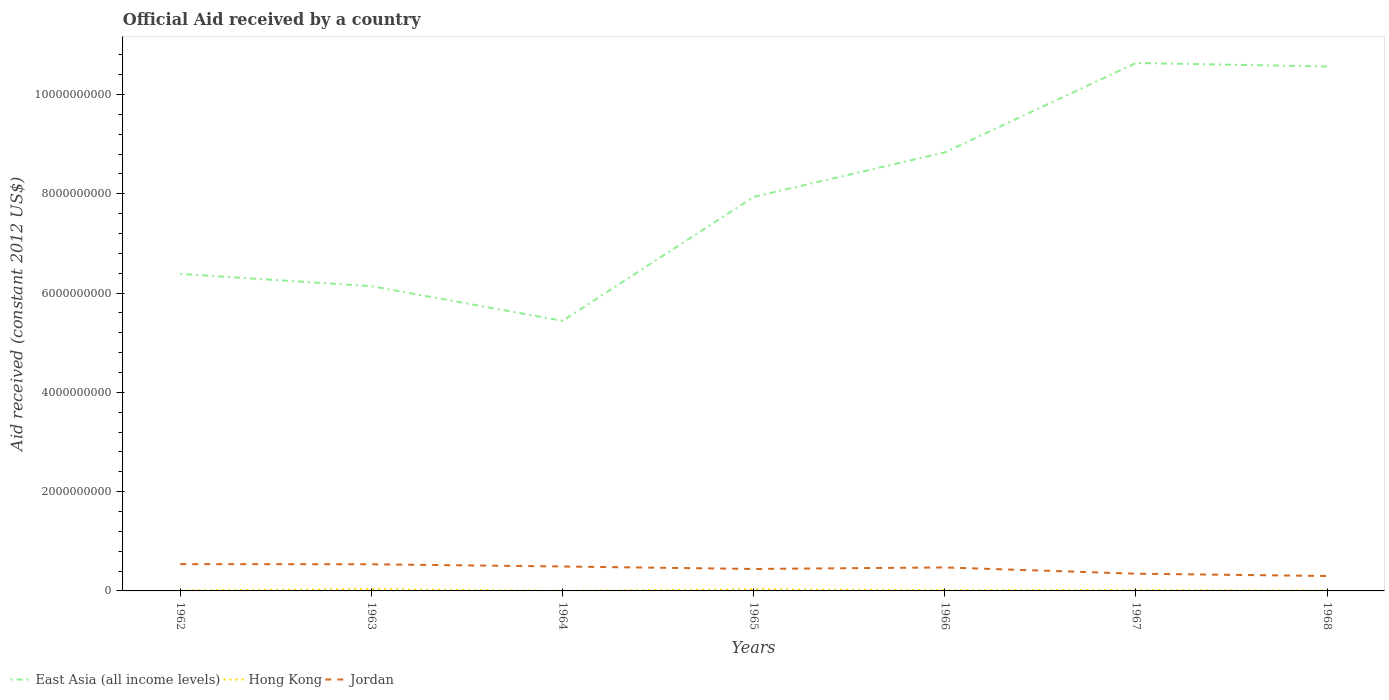How many different coloured lines are there?
Your answer should be very brief. 3. Is the number of lines equal to the number of legend labels?
Keep it short and to the point. Yes. Across all years, what is the maximum net official aid received in Hong Kong?
Offer a terse response. 2.08e+06. In which year was the net official aid received in East Asia (all income levels) maximum?
Your answer should be very brief. 1964. What is the total net official aid received in Jordan in the graph?
Your answer should be compact. 2.39e+08. What is the difference between the highest and the second highest net official aid received in Jordan?
Provide a succinct answer. 2.39e+08. Does the graph contain any zero values?
Give a very brief answer. No. Does the graph contain grids?
Offer a terse response. No. Where does the legend appear in the graph?
Make the answer very short. Bottom left. What is the title of the graph?
Your answer should be compact. Official Aid received by a country. Does "Romania" appear as one of the legend labels in the graph?
Your response must be concise. No. What is the label or title of the Y-axis?
Offer a terse response. Aid received (constant 2012 US$). What is the Aid received (constant 2012 US$) in East Asia (all income levels) in 1962?
Provide a short and direct response. 6.39e+09. What is the Aid received (constant 2012 US$) of Hong Kong in 1962?
Keep it short and to the point. 1.08e+07. What is the Aid received (constant 2012 US$) in Jordan in 1962?
Make the answer very short. 5.40e+08. What is the Aid received (constant 2012 US$) of East Asia (all income levels) in 1963?
Your answer should be very brief. 6.14e+09. What is the Aid received (constant 2012 US$) in Hong Kong in 1963?
Your answer should be compact. 3.70e+07. What is the Aid received (constant 2012 US$) of Jordan in 1963?
Offer a very short reply. 5.37e+08. What is the Aid received (constant 2012 US$) in East Asia (all income levels) in 1964?
Your answer should be compact. 5.44e+09. What is the Aid received (constant 2012 US$) in Hong Kong in 1964?
Offer a terse response. 2.08e+06. What is the Aid received (constant 2012 US$) of Jordan in 1964?
Provide a short and direct response. 4.92e+08. What is the Aid received (constant 2012 US$) in East Asia (all income levels) in 1965?
Make the answer very short. 7.94e+09. What is the Aid received (constant 2012 US$) in Hong Kong in 1965?
Keep it short and to the point. 3.34e+07. What is the Aid received (constant 2012 US$) of Jordan in 1965?
Offer a very short reply. 4.42e+08. What is the Aid received (constant 2012 US$) of East Asia (all income levels) in 1966?
Make the answer very short. 8.84e+09. What is the Aid received (constant 2012 US$) of Hong Kong in 1966?
Keep it short and to the point. 1.55e+07. What is the Aid received (constant 2012 US$) in Jordan in 1966?
Offer a terse response. 4.73e+08. What is the Aid received (constant 2012 US$) in East Asia (all income levels) in 1967?
Your response must be concise. 1.06e+1. What is the Aid received (constant 2012 US$) in Hong Kong in 1967?
Ensure brevity in your answer.  1.72e+07. What is the Aid received (constant 2012 US$) in Jordan in 1967?
Offer a terse response. 3.47e+08. What is the Aid received (constant 2012 US$) in East Asia (all income levels) in 1968?
Your response must be concise. 1.06e+1. What is the Aid received (constant 2012 US$) of Hong Kong in 1968?
Offer a terse response. 8.51e+06. What is the Aid received (constant 2012 US$) in Jordan in 1968?
Offer a terse response. 3.01e+08. Across all years, what is the maximum Aid received (constant 2012 US$) in East Asia (all income levels)?
Keep it short and to the point. 1.06e+1. Across all years, what is the maximum Aid received (constant 2012 US$) in Hong Kong?
Your answer should be compact. 3.70e+07. Across all years, what is the maximum Aid received (constant 2012 US$) in Jordan?
Your answer should be compact. 5.40e+08. Across all years, what is the minimum Aid received (constant 2012 US$) in East Asia (all income levels)?
Make the answer very short. 5.44e+09. Across all years, what is the minimum Aid received (constant 2012 US$) of Hong Kong?
Provide a short and direct response. 2.08e+06. Across all years, what is the minimum Aid received (constant 2012 US$) of Jordan?
Provide a succinct answer. 3.01e+08. What is the total Aid received (constant 2012 US$) in East Asia (all income levels) in the graph?
Give a very brief answer. 5.59e+1. What is the total Aid received (constant 2012 US$) in Hong Kong in the graph?
Make the answer very short. 1.24e+08. What is the total Aid received (constant 2012 US$) in Jordan in the graph?
Your answer should be very brief. 3.13e+09. What is the difference between the Aid received (constant 2012 US$) of East Asia (all income levels) in 1962 and that in 1963?
Make the answer very short. 2.47e+08. What is the difference between the Aid received (constant 2012 US$) of Hong Kong in 1962 and that in 1963?
Make the answer very short. -2.62e+07. What is the difference between the Aid received (constant 2012 US$) in Jordan in 1962 and that in 1963?
Your answer should be very brief. 2.85e+06. What is the difference between the Aid received (constant 2012 US$) of East Asia (all income levels) in 1962 and that in 1964?
Give a very brief answer. 9.46e+08. What is the difference between the Aid received (constant 2012 US$) in Hong Kong in 1962 and that in 1964?
Keep it short and to the point. 8.74e+06. What is the difference between the Aid received (constant 2012 US$) in Jordan in 1962 and that in 1964?
Offer a very short reply. 4.77e+07. What is the difference between the Aid received (constant 2012 US$) in East Asia (all income levels) in 1962 and that in 1965?
Your answer should be compact. -1.55e+09. What is the difference between the Aid received (constant 2012 US$) in Hong Kong in 1962 and that in 1965?
Keep it short and to the point. -2.26e+07. What is the difference between the Aid received (constant 2012 US$) in Jordan in 1962 and that in 1965?
Provide a succinct answer. 9.74e+07. What is the difference between the Aid received (constant 2012 US$) in East Asia (all income levels) in 1962 and that in 1966?
Keep it short and to the point. -2.45e+09. What is the difference between the Aid received (constant 2012 US$) in Hong Kong in 1962 and that in 1966?
Provide a succinct answer. -4.64e+06. What is the difference between the Aid received (constant 2012 US$) of Jordan in 1962 and that in 1966?
Give a very brief answer. 6.68e+07. What is the difference between the Aid received (constant 2012 US$) of East Asia (all income levels) in 1962 and that in 1967?
Make the answer very short. -4.25e+09. What is the difference between the Aid received (constant 2012 US$) in Hong Kong in 1962 and that in 1967?
Offer a terse response. -6.36e+06. What is the difference between the Aid received (constant 2012 US$) of Jordan in 1962 and that in 1967?
Provide a succinct answer. 1.93e+08. What is the difference between the Aid received (constant 2012 US$) in East Asia (all income levels) in 1962 and that in 1968?
Ensure brevity in your answer.  -4.18e+09. What is the difference between the Aid received (constant 2012 US$) in Hong Kong in 1962 and that in 1968?
Ensure brevity in your answer.  2.31e+06. What is the difference between the Aid received (constant 2012 US$) in Jordan in 1962 and that in 1968?
Give a very brief answer. 2.39e+08. What is the difference between the Aid received (constant 2012 US$) of East Asia (all income levels) in 1963 and that in 1964?
Ensure brevity in your answer.  6.99e+08. What is the difference between the Aid received (constant 2012 US$) in Hong Kong in 1963 and that in 1964?
Your answer should be compact. 3.50e+07. What is the difference between the Aid received (constant 2012 US$) in Jordan in 1963 and that in 1964?
Your answer should be very brief. 4.49e+07. What is the difference between the Aid received (constant 2012 US$) of East Asia (all income levels) in 1963 and that in 1965?
Your answer should be compact. -1.80e+09. What is the difference between the Aid received (constant 2012 US$) of Hong Kong in 1963 and that in 1965?
Offer a very short reply. 3.67e+06. What is the difference between the Aid received (constant 2012 US$) in Jordan in 1963 and that in 1965?
Your response must be concise. 9.45e+07. What is the difference between the Aid received (constant 2012 US$) of East Asia (all income levels) in 1963 and that in 1966?
Make the answer very short. -2.70e+09. What is the difference between the Aid received (constant 2012 US$) in Hong Kong in 1963 and that in 1966?
Your answer should be very brief. 2.16e+07. What is the difference between the Aid received (constant 2012 US$) of Jordan in 1963 and that in 1966?
Your response must be concise. 6.40e+07. What is the difference between the Aid received (constant 2012 US$) in East Asia (all income levels) in 1963 and that in 1967?
Your answer should be compact. -4.50e+09. What is the difference between the Aid received (constant 2012 US$) in Hong Kong in 1963 and that in 1967?
Provide a succinct answer. 1.99e+07. What is the difference between the Aid received (constant 2012 US$) in Jordan in 1963 and that in 1967?
Offer a very short reply. 1.90e+08. What is the difference between the Aid received (constant 2012 US$) in East Asia (all income levels) in 1963 and that in 1968?
Make the answer very short. -4.42e+09. What is the difference between the Aid received (constant 2012 US$) of Hong Kong in 1963 and that in 1968?
Your answer should be compact. 2.85e+07. What is the difference between the Aid received (constant 2012 US$) of Jordan in 1963 and that in 1968?
Ensure brevity in your answer.  2.36e+08. What is the difference between the Aid received (constant 2012 US$) in East Asia (all income levels) in 1964 and that in 1965?
Provide a short and direct response. -2.50e+09. What is the difference between the Aid received (constant 2012 US$) in Hong Kong in 1964 and that in 1965?
Your response must be concise. -3.13e+07. What is the difference between the Aid received (constant 2012 US$) in Jordan in 1964 and that in 1965?
Ensure brevity in your answer.  4.97e+07. What is the difference between the Aid received (constant 2012 US$) of East Asia (all income levels) in 1964 and that in 1966?
Provide a short and direct response. -3.39e+09. What is the difference between the Aid received (constant 2012 US$) of Hong Kong in 1964 and that in 1966?
Ensure brevity in your answer.  -1.34e+07. What is the difference between the Aid received (constant 2012 US$) of Jordan in 1964 and that in 1966?
Your answer should be very brief. 1.91e+07. What is the difference between the Aid received (constant 2012 US$) of East Asia (all income levels) in 1964 and that in 1967?
Give a very brief answer. -5.20e+09. What is the difference between the Aid received (constant 2012 US$) in Hong Kong in 1964 and that in 1967?
Provide a short and direct response. -1.51e+07. What is the difference between the Aid received (constant 2012 US$) of Jordan in 1964 and that in 1967?
Provide a succinct answer. 1.45e+08. What is the difference between the Aid received (constant 2012 US$) in East Asia (all income levels) in 1964 and that in 1968?
Keep it short and to the point. -5.12e+09. What is the difference between the Aid received (constant 2012 US$) of Hong Kong in 1964 and that in 1968?
Your answer should be compact. -6.43e+06. What is the difference between the Aid received (constant 2012 US$) in Jordan in 1964 and that in 1968?
Offer a terse response. 1.91e+08. What is the difference between the Aid received (constant 2012 US$) of East Asia (all income levels) in 1965 and that in 1966?
Offer a very short reply. -8.97e+08. What is the difference between the Aid received (constant 2012 US$) in Hong Kong in 1965 and that in 1966?
Your answer should be very brief. 1.79e+07. What is the difference between the Aid received (constant 2012 US$) of Jordan in 1965 and that in 1966?
Give a very brief answer. -3.06e+07. What is the difference between the Aid received (constant 2012 US$) in East Asia (all income levels) in 1965 and that in 1967?
Your answer should be compact. -2.70e+09. What is the difference between the Aid received (constant 2012 US$) in Hong Kong in 1965 and that in 1967?
Provide a short and direct response. 1.62e+07. What is the difference between the Aid received (constant 2012 US$) of Jordan in 1965 and that in 1967?
Your answer should be very brief. 9.51e+07. What is the difference between the Aid received (constant 2012 US$) of East Asia (all income levels) in 1965 and that in 1968?
Make the answer very short. -2.63e+09. What is the difference between the Aid received (constant 2012 US$) in Hong Kong in 1965 and that in 1968?
Your answer should be very brief. 2.49e+07. What is the difference between the Aid received (constant 2012 US$) in Jordan in 1965 and that in 1968?
Make the answer very short. 1.42e+08. What is the difference between the Aid received (constant 2012 US$) of East Asia (all income levels) in 1966 and that in 1967?
Your answer should be very brief. -1.80e+09. What is the difference between the Aid received (constant 2012 US$) of Hong Kong in 1966 and that in 1967?
Keep it short and to the point. -1.72e+06. What is the difference between the Aid received (constant 2012 US$) of Jordan in 1966 and that in 1967?
Ensure brevity in your answer.  1.26e+08. What is the difference between the Aid received (constant 2012 US$) in East Asia (all income levels) in 1966 and that in 1968?
Provide a succinct answer. -1.73e+09. What is the difference between the Aid received (constant 2012 US$) in Hong Kong in 1966 and that in 1968?
Ensure brevity in your answer.  6.95e+06. What is the difference between the Aid received (constant 2012 US$) in Jordan in 1966 and that in 1968?
Ensure brevity in your answer.  1.72e+08. What is the difference between the Aid received (constant 2012 US$) in East Asia (all income levels) in 1967 and that in 1968?
Your answer should be very brief. 7.13e+07. What is the difference between the Aid received (constant 2012 US$) of Hong Kong in 1967 and that in 1968?
Your response must be concise. 8.67e+06. What is the difference between the Aid received (constant 2012 US$) of Jordan in 1967 and that in 1968?
Offer a terse response. 4.67e+07. What is the difference between the Aid received (constant 2012 US$) in East Asia (all income levels) in 1962 and the Aid received (constant 2012 US$) in Hong Kong in 1963?
Give a very brief answer. 6.35e+09. What is the difference between the Aid received (constant 2012 US$) of East Asia (all income levels) in 1962 and the Aid received (constant 2012 US$) of Jordan in 1963?
Your answer should be compact. 5.85e+09. What is the difference between the Aid received (constant 2012 US$) in Hong Kong in 1962 and the Aid received (constant 2012 US$) in Jordan in 1963?
Keep it short and to the point. -5.26e+08. What is the difference between the Aid received (constant 2012 US$) of East Asia (all income levels) in 1962 and the Aid received (constant 2012 US$) of Hong Kong in 1964?
Your answer should be compact. 6.38e+09. What is the difference between the Aid received (constant 2012 US$) of East Asia (all income levels) in 1962 and the Aid received (constant 2012 US$) of Jordan in 1964?
Your answer should be very brief. 5.89e+09. What is the difference between the Aid received (constant 2012 US$) of Hong Kong in 1962 and the Aid received (constant 2012 US$) of Jordan in 1964?
Offer a terse response. -4.81e+08. What is the difference between the Aid received (constant 2012 US$) of East Asia (all income levels) in 1962 and the Aid received (constant 2012 US$) of Hong Kong in 1965?
Your answer should be compact. 6.35e+09. What is the difference between the Aid received (constant 2012 US$) of East Asia (all income levels) in 1962 and the Aid received (constant 2012 US$) of Jordan in 1965?
Your answer should be very brief. 5.94e+09. What is the difference between the Aid received (constant 2012 US$) in Hong Kong in 1962 and the Aid received (constant 2012 US$) in Jordan in 1965?
Offer a terse response. -4.32e+08. What is the difference between the Aid received (constant 2012 US$) in East Asia (all income levels) in 1962 and the Aid received (constant 2012 US$) in Hong Kong in 1966?
Offer a terse response. 6.37e+09. What is the difference between the Aid received (constant 2012 US$) in East Asia (all income levels) in 1962 and the Aid received (constant 2012 US$) in Jordan in 1966?
Give a very brief answer. 5.91e+09. What is the difference between the Aid received (constant 2012 US$) of Hong Kong in 1962 and the Aid received (constant 2012 US$) of Jordan in 1966?
Your answer should be very brief. -4.62e+08. What is the difference between the Aid received (constant 2012 US$) in East Asia (all income levels) in 1962 and the Aid received (constant 2012 US$) in Hong Kong in 1967?
Offer a very short reply. 6.37e+09. What is the difference between the Aid received (constant 2012 US$) of East Asia (all income levels) in 1962 and the Aid received (constant 2012 US$) of Jordan in 1967?
Give a very brief answer. 6.04e+09. What is the difference between the Aid received (constant 2012 US$) in Hong Kong in 1962 and the Aid received (constant 2012 US$) in Jordan in 1967?
Provide a succinct answer. -3.36e+08. What is the difference between the Aid received (constant 2012 US$) in East Asia (all income levels) in 1962 and the Aid received (constant 2012 US$) in Hong Kong in 1968?
Your answer should be compact. 6.38e+09. What is the difference between the Aid received (constant 2012 US$) in East Asia (all income levels) in 1962 and the Aid received (constant 2012 US$) in Jordan in 1968?
Provide a succinct answer. 6.09e+09. What is the difference between the Aid received (constant 2012 US$) in Hong Kong in 1962 and the Aid received (constant 2012 US$) in Jordan in 1968?
Give a very brief answer. -2.90e+08. What is the difference between the Aid received (constant 2012 US$) in East Asia (all income levels) in 1963 and the Aid received (constant 2012 US$) in Hong Kong in 1964?
Your response must be concise. 6.14e+09. What is the difference between the Aid received (constant 2012 US$) in East Asia (all income levels) in 1963 and the Aid received (constant 2012 US$) in Jordan in 1964?
Ensure brevity in your answer.  5.65e+09. What is the difference between the Aid received (constant 2012 US$) of Hong Kong in 1963 and the Aid received (constant 2012 US$) of Jordan in 1964?
Ensure brevity in your answer.  -4.55e+08. What is the difference between the Aid received (constant 2012 US$) in East Asia (all income levels) in 1963 and the Aid received (constant 2012 US$) in Hong Kong in 1965?
Offer a terse response. 6.11e+09. What is the difference between the Aid received (constant 2012 US$) of East Asia (all income levels) in 1963 and the Aid received (constant 2012 US$) of Jordan in 1965?
Offer a very short reply. 5.70e+09. What is the difference between the Aid received (constant 2012 US$) of Hong Kong in 1963 and the Aid received (constant 2012 US$) of Jordan in 1965?
Offer a terse response. -4.05e+08. What is the difference between the Aid received (constant 2012 US$) in East Asia (all income levels) in 1963 and the Aid received (constant 2012 US$) in Hong Kong in 1966?
Offer a very short reply. 6.12e+09. What is the difference between the Aid received (constant 2012 US$) of East Asia (all income levels) in 1963 and the Aid received (constant 2012 US$) of Jordan in 1966?
Ensure brevity in your answer.  5.67e+09. What is the difference between the Aid received (constant 2012 US$) in Hong Kong in 1963 and the Aid received (constant 2012 US$) in Jordan in 1966?
Ensure brevity in your answer.  -4.36e+08. What is the difference between the Aid received (constant 2012 US$) in East Asia (all income levels) in 1963 and the Aid received (constant 2012 US$) in Hong Kong in 1967?
Keep it short and to the point. 6.12e+09. What is the difference between the Aid received (constant 2012 US$) in East Asia (all income levels) in 1963 and the Aid received (constant 2012 US$) in Jordan in 1967?
Provide a short and direct response. 5.79e+09. What is the difference between the Aid received (constant 2012 US$) in Hong Kong in 1963 and the Aid received (constant 2012 US$) in Jordan in 1967?
Your answer should be very brief. -3.10e+08. What is the difference between the Aid received (constant 2012 US$) in East Asia (all income levels) in 1963 and the Aid received (constant 2012 US$) in Hong Kong in 1968?
Give a very brief answer. 6.13e+09. What is the difference between the Aid received (constant 2012 US$) in East Asia (all income levels) in 1963 and the Aid received (constant 2012 US$) in Jordan in 1968?
Provide a succinct answer. 5.84e+09. What is the difference between the Aid received (constant 2012 US$) of Hong Kong in 1963 and the Aid received (constant 2012 US$) of Jordan in 1968?
Offer a very short reply. -2.64e+08. What is the difference between the Aid received (constant 2012 US$) of East Asia (all income levels) in 1964 and the Aid received (constant 2012 US$) of Hong Kong in 1965?
Give a very brief answer. 5.41e+09. What is the difference between the Aid received (constant 2012 US$) in East Asia (all income levels) in 1964 and the Aid received (constant 2012 US$) in Jordan in 1965?
Ensure brevity in your answer.  5.00e+09. What is the difference between the Aid received (constant 2012 US$) of Hong Kong in 1964 and the Aid received (constant 2012 US$) of Jordan in 1965?
Provide a succinct answer. -4.40e+08. What is the difference between the Aid received (constant 2012 US$) of East Asia (all income levels) in 1964 and the Aid received (constant 2012 US$) of Hong Kong in 1966?
Offer a terse response. 5.42e+09. What is the difference between the Aid received (constant 2012 US$) of East Asia (all income levels) in 1964 and the Aid received (constant 2012 US$) of Jordan in 1966?
Your answer should be very brief. 4.97e+09. What is the difference between the Aid received (constant 2012 US$) in Hong Kong in 1964 and the Aid received (constant 2012 US$) in Jordan in 1966?
Make the answer very short. -4.71e+08. What is the difference between the Aid received (constant 2012 US$) of East Asia (all income levels) in 1964 and the Aid received (constant 2012 US$) of Hong Kong in 1967?
Give a very brief answer. 5.42e+09. What is the difference between the Aid received (constant 2012 US$) of East Asia (all income levels) in 1964 and the Aid received (constant 2012 US$) of Jordan in 1967?
Your answer should be compact. 5.09e+09. What is the difference between the Aid received (constant 2012 US$) of Hong Kong in 1964 and the Aid received (constant 2012 US$) of Jordan in 1967?
Your response must be concise. -3.45e+08. What is the difference between the Aid received (constant 2012 US$) in East Asia (all income levels) in 1964 and the Aid received (constant 2012 US$) in Hong Kong in 1968?
Your response must be concise. 5.43e+09. What is the difference between the Aid received (constant 2012 US$) in East Asia (all income levels) in 1964 and the Aid received (constant 2012 US$) in Jordan in 1968?
Your answer should be compact. 5.14e+09. What is the difference between the Aid received (constant 2012 US$) of Hong Kong in 1964 and the Aid received (constant 2012 US$) of Jordan in 1968?
Your response must be concise. -2.99e+08. What is the difference between the Aid received (constant 2012 US$) in East Asia (all income levels) in 1965 and the Aid received (constant 2012 US$) in Hong Kong in 1966?
Make the answer very short. 7.92e+09. What is the difference between the Aid received (constant 2012 US$) of East Asia (all income levels) in 1965 and the Aid received (constant 2012 US$) of Jordan in 1966?
Ensure brevity in your answer.  7.46e+09. What is the difference between the Aid received (constant 2012 US$) in Hong Kong in 1965 and the Aid received (constant 2012 US$) in Jordan in 1966?
Your response must be concise. -4.40e+08. What is the difference between the Aid received (constant 2012 US$) in East Asia (all income levels) in 1965 and the Aid received (constant 2012 US$) in Hong Kong in 1967?
Offer a very short reply. 7.92e+09. What is the difference between the Aid received (constant 2012 US$) in East Asia (all income levels) in 1965 and the Aid received (constant 2012 US$) in Jordan in 1967?
Offer a very short reply. 7.59e+09. What is the difference between the Aid received (constant 2012 US$) of Hong Kong in 1965 and the Aid received (constant 2012 US$) of Jordan in 1967?
Provide a short and direct response. -3.14e+08. What is the difference between the Aid received (constant 2012 US$) in East Asia (all income levels) in 1965 and the Aid received (constant 2012 US$) in Hong Kong in 1968?
Your answer should be compact. 7.93e+09. What is the difference between the Aid received (constant 2012 US$) in East Asia (all income levels) in 1965 and the Aid received (constant 2012 US$) in Jordan in 1968?
Provide a succinct answer. 7.64e+09. What is the difference between the Aid received (constant 2012 US$) of Hong Kong in 1965 and the Aid received (constant 2012 US$) of Jordan in 1968?
Provide a short and direct response. -2.67e+08. What is the difference between the Aid received (constant 2012 US$) in East Asia (all income levels) in 1966 and the Aid received (constant 2012 US$) in Hong Kong in 1967?
Keep it short and to the point. 8.82e+09. What is the difference between the Aid received (constant 2012 US$) of East Asia (all income levels) in 1966 and the Aid received (constant 2012 US$) of Jordan in 1967?
Offer a terse response. 8.49e+09. What is the difference between the Aid received (constant 2012 US$) in Hong Kong in 1966 and the Aid received (constant 2012 US$) in Jordan in 1967?
Give a very brief answer. -3.32e+08. What is the difference between the Aid received (constant 2012 US$) of East Asia (all income levels) in 1966 and the Aid received (constant 2012 US$) of Hong Kong in 1968?
Provide a succinct answer. 8.83e+09. What is the difference between the Aid received (constant 2012 US$) of East Asia (all income levels) in 1966 and the Aid received (constant 2012 US$) of Jordan in 1968?
Offer a very short reply. 8.53e+09. What is the difference between the Aid received (constant 2012 US$) in Hong Kong in 1966 and the Aid received (constant 2012 US$) in Jordan in 1968?
Provide a short and direct response. -2.85e+08. What is the difference between the Aid received (constant 2012 US$) of East Asia (all income levels) in 1967 and the Aid received (constant 2012 US$) of Hong Kong in 1968?
Give a very brief answer. 1.06e+1. What is the difference between the Aid received (constant 2012 US$) of East Asia (all income levels) in 1967 and the Aid received (constant 2012 US$) of Jordan in 1968?
Give a very brief answer. 1.03e+1. What is the difference between the Aid received (constant 2012 US$) in Hong Kong in 1967 and the Aid received (constant 2012 US$) in Jordan in 1968?
Offer a terse response. -2.83e+08. What is the average Aid received (constant 2012 US$) in East Asia (all income levels) per year?
Provide a short and direct response. 7.99e+09. What is the average Aid received (constant 2012 US$) of Hong Kong per year?
Give a very brief answer. 1.78e+07. What is the average Aid received (constant 2012 US$) in Jordan per year?
Your answer should be compact. 4.47e+08. In the year 1962, what is the difference between the Aid received (constant 2012 US$) in East Asia (all income levels) and Aid received (constant 2012 US$) in Hong Kong?
Provide a succinct answer. 6.38e+09. In the year 1962, what is the difference between the Aid received (constant 2012 US$) in East Asia (all income levels) and Aid received (constant 2012 US$) in Jordan?
Make the answer very short. 5.85e+09. In the year 1962, what is the difference between the Aid received (constant 2012 US$) in Hong Kong and Aid received (constant 2012 US$) in Jordan?
Make the answer very short. -5.29e+08. In the year 1963, what is the difference between the Aid received (constant 2012 US$) of East Asia (all income levels) and Aid received (constant 2012 US$) of Hong Kong?
Provide a succinct answer. 6.10e+09. In the year 1963, what is the difference between the Aid received (constant 2012 US$) in East Asia (all income levels) and Aid received (constant 2012 US$) in Jordan?
Make the answer very short. 5.60e+09. In the year 1963, what is the difference between the Aid received (constant 2012 US$) of Hong Kong and Aid received (constant 2012 US$) of Jordan?
Keep it short and to the point. -5.00e+08. In the year 1964, what is the difference between the Aid received (constant 2012 US$) in East Asia (all income levels) and Aid received (constant 2012 US$) in Hong Kong?
Your response must be concise. 5.44e+09. In the year 1964, what is the difference between the Aid received (constant 2012 US$) of East Asia (all income levels) and Aid received (constant 2012 US$) of Jordan?
Provide a short and direct response. 4.95e+09. In the year 1964, what is the difference between the Aid received (constant 2012 US$) of Hong Kong and Aid received (constant 2012 US$) of Jordan?
Make the answer very short. -4.90e+08. In the year 1965, what is the difference between the Aid received (constant 2012 US$) in East Asia (all income levels) and Aid received (constant 2012 US$) in Hong Kong?
Offer a terse response. 7.90e+09. In the year 1965, what is the difference between the Aid received (constant 2012 US$) of East Asia (all income levels) and Aid received (constant 2012 US$) of Jordan?
Offer a terse response. 7.50e+09. In the year 1965, what is the difference between the Aid received (constant 2012 US$) of Hong Kong and Aid received (constant 2012 US$) of Jordan?
Offer a terse response. -4.09e+08. In the year 1966, what is the difference between the Aid received (constant 2012 US$) in East Asia (all income levels) and Aid received (constant 2012 US$) in Hong Kong?
Offer a very short reply. 8.82e+09. In the year 1966, what is the difference between the Aid received (constant 2012 US$) of East Asia (all income levels) and Aid received (constant 2012 US$) of Jordan?
Offer a terse response. 8.36e+09. In the year 1966, what is the difference between the Aid received (constant 2012 US$) in Hong Kong and Aid received (constant 2012 US$) in Jordan?
Make the answer very short. -4.58e+08. In the year 1967, what is the difference between the Aid received (constant 2012 US$) of East Asia (all income levels) and Aid received (constant 2012 US$) of Hong Kong?
Offer a terse response. 1.06e+1. In the year 1967, what is the difference between the Aid received (constant 2012 US$) in East Asia (all income levels) and Aid received (constant 2012 US$) in Jordan?
Provide a succinct answer. 1.03e+1. In the year 1967, what is the difference between the Aid received (constant 2012 US$) of Hong Kong and Aid received (constant 2012 US$) of Jordan?
Your answer should be compact. -3.30e+08. In the year 1968, what is the difference between the Aid received (constant 2012 US$) of East Asia (all income levels) and Aid received (constant 2012 US$) of Hong Kong?
Make the answer very short. 1.06e+1. In the year 1968, what is the difference between the Aid received (constant 2012 US$) in East Asia (all income levels) and Aid received (constant 2012 US$) in Jordan?
Offer a terse response. 1.03e+1. In the year 1968, what is the difference between the Aid received (constant 2012 US$) in Hong Kong and Aid received (constant 2012 US$) in Jordan?
Give a very brief answer. -2.92e+08. What is the ratio of the Aid received (constant 2012 US$) of East Asia (all income levels) in 1962 to that in 1963?
Your answer should be very brief. 1.04. What is the ratio of the Aid received (constant 2012 US$) of Hong Kong in 1962 to that in 1963?
Offer a very short reply. 0.29. What is the ratio of the Aid received (constant 2012 US$) of Jordan in 1962 to that in 1963?
Offer a terse response. 1.01. What is the ratio of the Aid received (constant 2012 US$) of East Asia (all income levels) in 1962 to that in 1964?
Keep it short and to the point. 1.17. What is the ratio of the Aid received (constant 2012 US$) of Hong Kong in 1962 to that in 1964?
Your answer should be compact. 5.2. What is the ratio of the Aid received (constant 2012 US$) in Jordan in 1962 to that in 1964?
Your answer should be compact. 1.1. What is the ratio of the Aid received (constant 2012 US$) of East Asia (all income levels) in 1962 to that in 1965?
Ensure brevity in your answer.  0.8. What is the ratio of the Aid received (constant 2012 US$) in Hong Kong in 1962 to that in 1965?
Keep it short and to the point. 0.32. What is the ratio of the Aid received (constant 2012 US$) in Jordan in 1962 to that in 1965?
Offer a terse response. 1.22. What is the ratio of the Aid received (constant 2012 US$) in East Asia (all income levels) in 1962 to that in 1966?
Provide a short and direct response. 0.72. What is the ratio of the Aid received (constant 2012 US$) of Hong Kong in 1962 to that in 1966?
Provide a succinct answer. 0.7. What is the ratio of the Aid received (constant 2012 US$) in Jordan in 1962 to that in 1966?
Provide a short and direct response. 1.14. What is the ratio of the Aid received (constant 2012 US$) of East Asia (all income levels) in 1962 to that in 1967?
Your answer should be very brief. 0.6. What is the ratio of the Aid received (constant 2012 US$) in Hong Kong in 1962 to that in 1967?
Give a very brief answer. 0.63. What is the ratio of the Aid received (constant 2012 US$) of Jordan in 1962 to that in 1967?
Provide a succinct answer. 1.55. What is the ratio of the Aid received (constant 2012 US$) in East Asia (all income levels) in 1962 to that in 1968?
Give a very brief answer. 0.6. What is the ratio of the Aid received (constant 2012 US$) of Hong Kong in 1962 to that in 1968?
Provide a short and direct response. 1.27. What is the ratio of the Aid received (constant 2012 US$) of Jordan in 1962 to that in 1968?
Your answer should be very brief. 1.8. What is the ratio of the Aid received (constant 2012 US$) in East Asia (all income levels) in 1963 to that in 1964?
Your response must be concise. 1.13. What is the ratio of the Aid received (constant 2012 US$) in Hong Kong in 1963 to that in 1964?
Your response must be concise. 17.81. What is the ratio of the Aid received (constant 2012 US$) in Jordan in 1963 to that in 1964?
Provide a succinct answer. 1.09. What is the ratio of the Aid received (constant 2012 US$) in East Asia (all income levels) in 1963 to that in 1965?
Provide a succinct answer. 0.77. What is the ratio of the Aid received (constant 2012 US$) of Hong Kong in 1963 to that in 1965?
Your answer should be compact. 1.11. What is the ratio of the Aid received (constant 2012 US$) in Jordan in 1963 to that in 1965?
Your answer should be compact. 1.21. What is the ratio of the Aid received (constant 2012 US$) of East Asia (all income levels) in 1963 to that in 1966?
Ensure brevity in your answer.  0.69. What is the ratio of the Aid received (constant 2012 US$) of Hong Kong in 1963 to that in 1966?
Provide a short and direct response. 2.4. What is the ratio of the Aid received (constant 2012 US$) in Jordan in 1963 to that in 1966?
Ensure brevity in your answer.  1.14. What is the ratio of the Aid received (constant 2012 US$) of East Asia (all income levels) in 1963 to that in 1967?
Keep it short and to the point. 0.58. What is the ratio of the Aid received (constant 2012 US$) of Hong Kong in 1963 to that in 1967?
Your answer should be compact. 2.16. What is the ratio of the Aid received (constant 2012 US$) in Jordan in 1963 to that in 1967?
Make the answer very short. 1.55. What is the ratio of the Aid received (constant 2012 US$) in East Asia (all income levels) in 1963 to that in 1968?
Provide a short and direct response. 0.58. What is the ratio of the Aid received (constant 2012 US$) of Hong Kong in 1963 to that in 1968?
Make the answer very short. 4.35. What is the ratio of the Aid received (constant 2012 US$) in Jordan in 1963 to that in 1968?
Your response must be concise. 1.79. What is the ratio of the Aid received (constant 2012 US$) of East Asia (all income levels) in 1964 to that in 1965?
Provide a succinct answer. 0.69. What is the ratio of the Aid received (constant 2012 US$) in Hong Kong in 1964 to that in 1965?
Your answer should be very brief. 0.06. What is the ratio of the Aid received (constant 2012 US$) in Jordan in 1964 to that in 1965?
Provide a succinct answer. 1.11. What is the ratio of the Aid received (constant 2012 US$) in East Asia (all income levels) in 1964 to that in 1966?
Provide a succinct answer. 0.62. What is the ratio of the Aid received (constant 2012 US$) in Hong Kong in 1964 to that in 1966?
Ensure brevity in your answer.  0.13. What is the ratio of the Aid received (constant 2012 US$) of Jordan in 1964 to that in 1966?
Offer a very short reply. 1.04. What is the ratio of the Aid received (constant 2012 US$) in East Asia (all income levels) in 1964 to that in 1967?
Offer a terse response. 0.51. What is the ratio of the Aid received (constant 2012 US$) of Hong Kong in 1964 to that in 1967?
Give a very brief answer. 0.12. What is the ratio of the Aid received (constant 2012 US$) in Jordan in 1964 to that in 1967?
Provide a succinct answer. 1.42. What is the ratio of the Aid received (constant 2012 US$) of East Asia (all income levels) in 1964 to that in 1968?
Offer a very short reply. 0.52. What is the ratio of the Aid received (constant 2012 US$) in Hong Kong in 1964 to that in 1968?
Your response must be concise. 0.24. What is the ratio of the Aid received (constant 2012 US$) of Jordan in 1964 to that in 1968?
Offer a terse response. 1.64. What is the ratio of the Aid received (constant 2012 US$) of East Asia (all income levels) in 1965 to that in 1966?
Give a very brief answer. 0.9. What is the ratio of the Aid received (constant 2012 US$) in Hong Kong in 1965 to that in 1966?
Offer a very short reply. 2.16. What is the ratio of the Aid received (constant 2012 US$) in Jordan in 1965 to that in 1966?
Your answer should be very brief. 0.94. What is the ratio of the Aid received (constant 2012 US$) of East Asia (all income levels) in 1965 to that in 1967?
Give a very brief answer. 0.75. What is the ratio of the Aid received (constant 2012 US$) in Hong Kong in 1965 to that in 1967?
Offer a terse response. 1.94. What is the ratio of the Aid received (constant 2012 US$) in Jordan in 1965 to that in 1967?
Keep it short and to the point. 1.27. What is the ratio of the Aid received (constant 2012 US$) in East Asia (all income levels) in 1965 to that in 1968?
Make the answer very short. 0.75. What is the ratio of the Aid received (constant 2012 US$) of Hong Kong in 1965 to that in 1968?
Ensure brevity in your answer.  3.92. What is the ratio of the Aid received (constant 2012 US$) in Jordan in 1965 to that in 1968?
Offer a terse response. 1.47. What is the ratio of the Aid received (constant 2012 US$) in East Asia (all income levels) in 1966 to that in 1967?
Your response must be concise. 0.83. What is the ratio of the Aid received (constant 2012 US$) of Hong Kong in 1966 to that in 1967?
Your answer should be very brief. 0.9. What is the ratio of the Aid received (constant 2012 US$) in Jordan in 1966 to that in 1967?
Provide a short and direct response. 1.36. What is the ratio of the Aid received (constant 2012 US$) of East Asia (all income levels) in 1966 to that in 1968?
Your answer should be very brief. 0.84. What is the ratio of the Aid received (constant 2012 US$) of Hong Kong in 1966 to that in 1968?
Provide a short and direct response. 1.82. What is the ratio of the Aid received (constant 2012 US$) of Jordan in 1966 to that in 1968?
Provide a succinct answer. 1.57. What is the ratio of the Aid received (constant 2012 US$) in East Asia (all income levels) in 1967 to that in 1968?
Your answer should be compact. 1.01. What is the ratio of the Aid received (constant 2012 US$) in Hong Kong in 1967 to that in 1968?
Provide a succinct answer. 2.02. What is the ratio of the Aid received (constant 2012 US$) of Jordan in 1967 to that in 1968?
Provide a short and direct response. 1.16. What is the difference between the highest and the second highest Aid received (constant 2012 US$) of East Asia (all income levels)?
Make the answer very short. 7.13e+07. What is the difference between the highest and the second highest Aid received (constant 2012 US$) in Hong Kong?
Your answer should be very brief. 3.67e+06. What is the difference between the highest and the second highest Aid received (constant 2012 US$) of Jordan?
Ensure brevity in your answer.  2.85e+06. What is the difference between the highest and the lowest Aid received (constant 2012 US$) of East Asia (all income levels)?
Give a very brief answer. 5.20e+09. What is the difference between the highest and the lowest Aid received (constant 2012 US$) of Hong Kong?
Your answer should be compact. 3.50e+07. What is the difference between the highest and the lowest Aid received (constant 2012 US$) of Jordan?
Make the answer very short. 2.39e+08. 